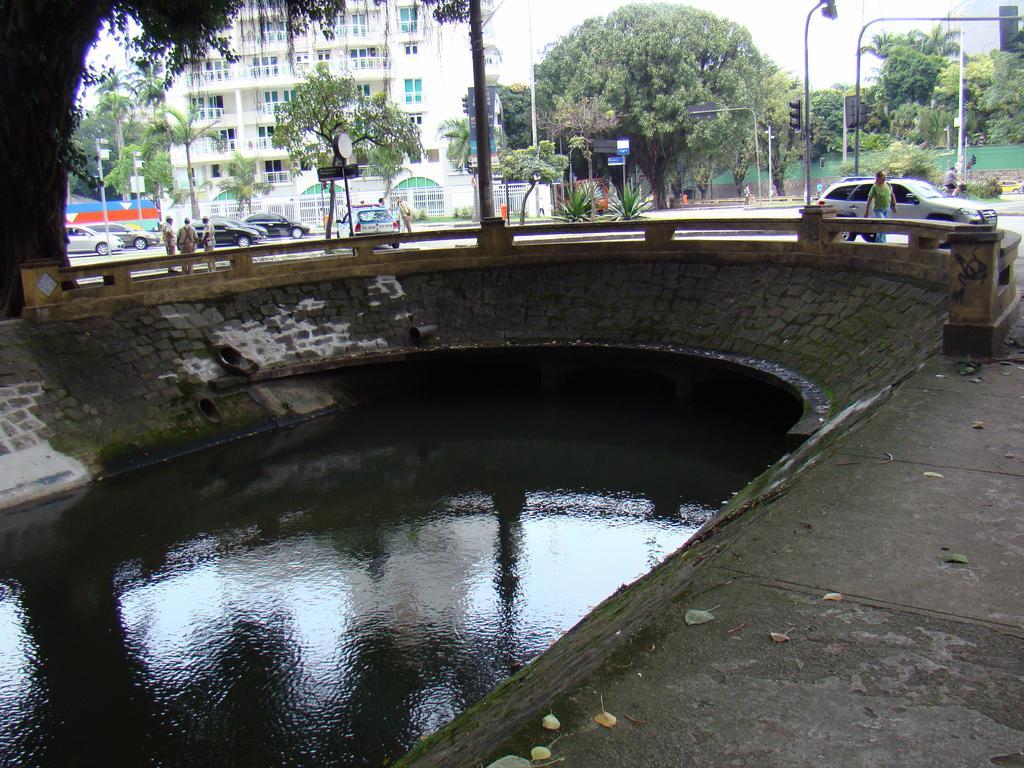Describe this image in one or two sentences. In the image there is a pond on the left side with a road behind it and vehicles moving on it and some persons walking on the foot path, in the back there is a building with many trees in front of it. 